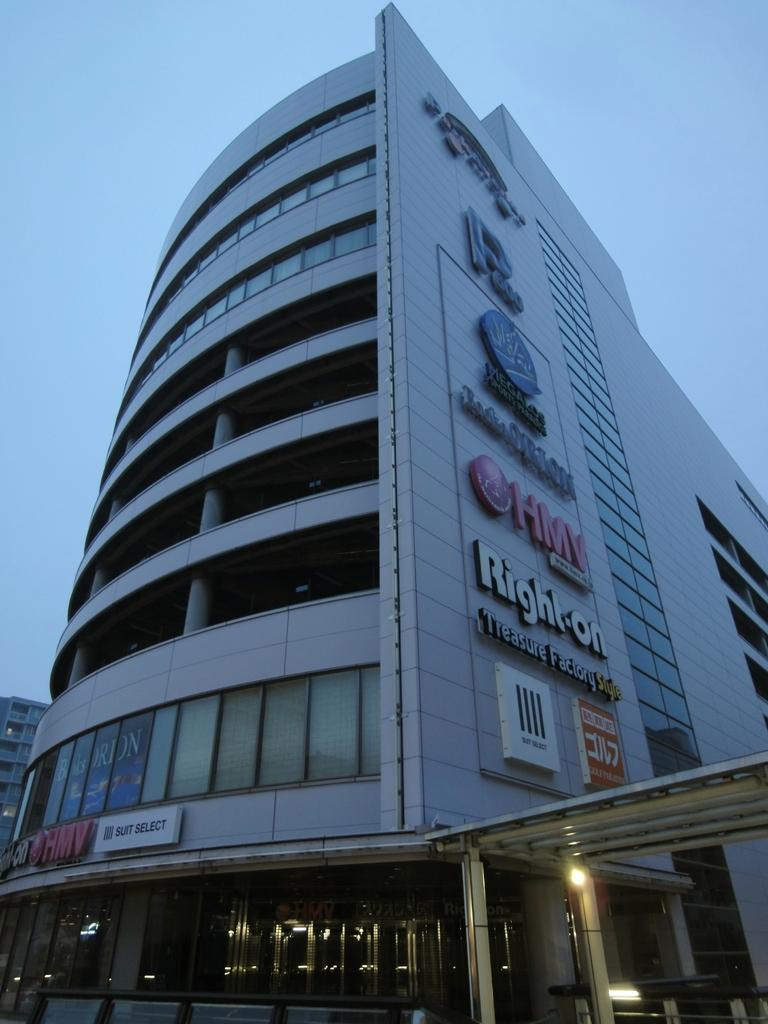What type of structure is present in the image? There is a building in the image. Can you describe another structure in the image? There is a shed in the bottom right corner of the image. What feature can be seen inside the shed? A light is attached to a pillar in the shed. What is visible at the top of the image? The sky is visible at the top of the image. What type of muscle is being exercised by the fireman in the image? There is no fireman present in the image, so it is not possible to determine which muscle is being exercised. 